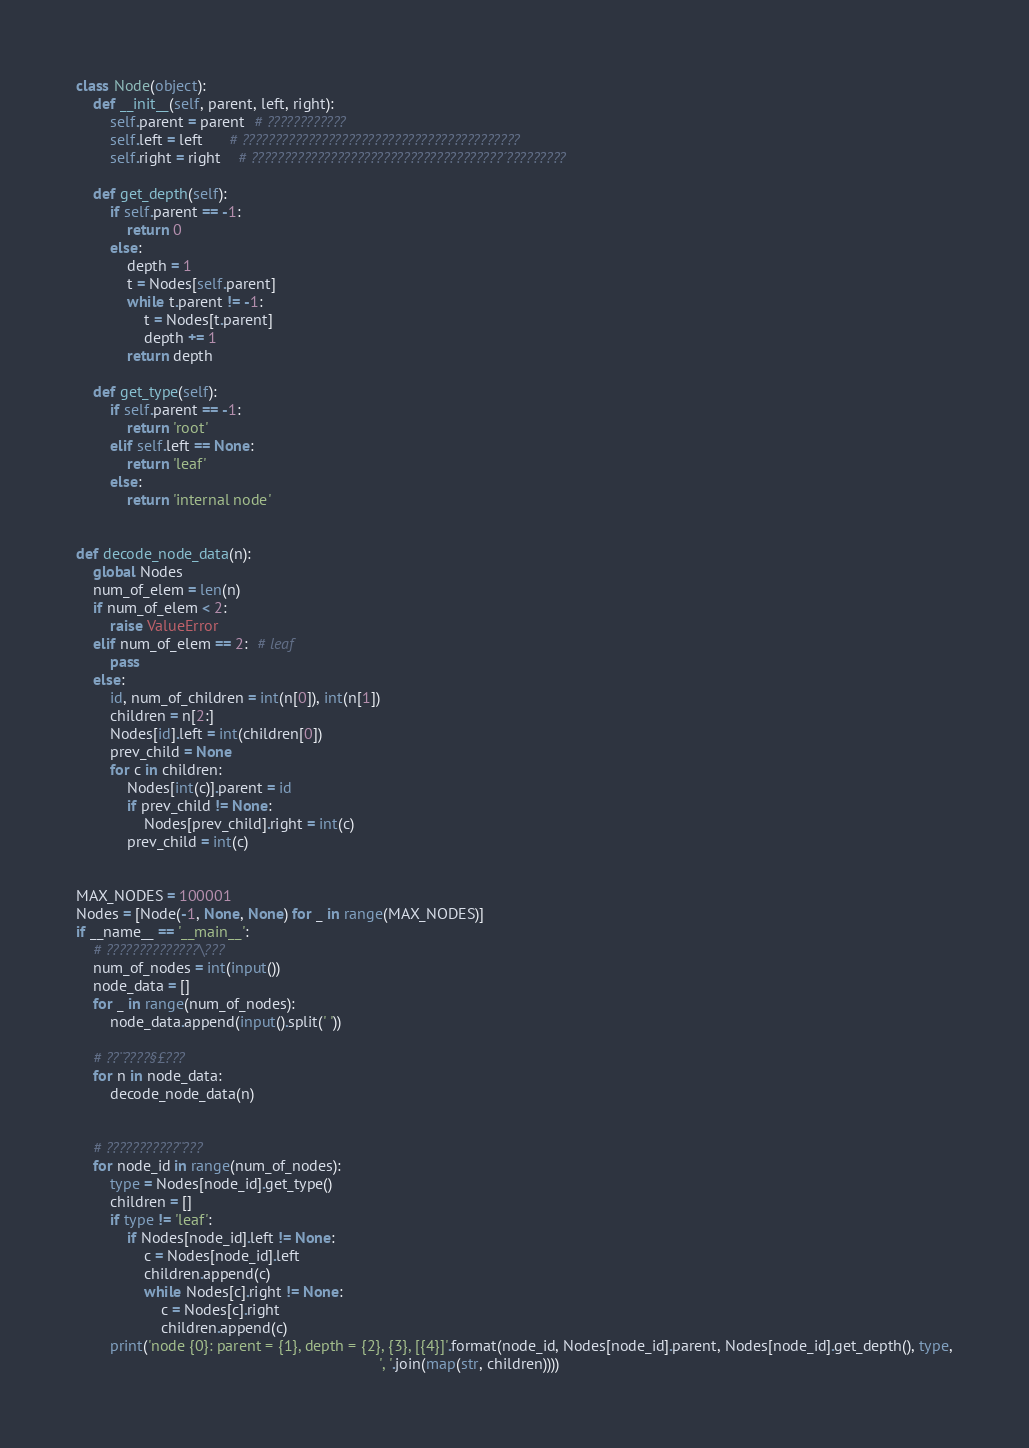Convert code to text. <code><loc_0><loc_0><loc_500><loc_500><_Python_>class Node(object):
    def __init__(self, parent, left, right):
        self.parent = parent  # ????????????
        self.left = left      # ??????????????????????????????????????????
        self.right = right    # ??????????????????????????????????????´?????????

    def get_depth(self):
        if self.parent == -1:
            return 0
        else:
            depth = 1
            t = Nodes[self.parent]
            while t.parent != -1:
                t = Nodes[t.parent]
                depth += 1
            return depth

    def get_type(self):
        if self.parent == -1:
            return 'root'
        elif self.left == None:
            return 'leaf'
        else:
            return 'internal node'


def decode_node_data(n):
    global Nodes
    num_of_elem = len(n)
    if num_of_elem < 2:
        raise ValueError
    elif num_of_elem == 2:  # leaf
        pass
    else:
        id, num_of_children = int(n[0]), int(n[1])
        children = n[2:]
        Nodes[id].left = int(children[0])
        prev_child = None
        for c in children:
            Nodes[int(c)].parent = id
            if prev_child != None:
                Nodes[prev_child].right = int(c)
            prev_child = int(c)


MAX_NODES = 100001
Nodes = [Node(-1, None, None) for _ in range(MAX_NODES)]
if __name__ == '__main__':
    # ??????????????\???
    num_of_nodes = int(input())
    node_data = []
    for _ in range(num_of_nodes):
        node_data.append(input().split(' '))

    # ??¨????§£???
    for n in node_data:
        decode_node_data(n)


    # ???????????¨???
    for node_id in range(num_of_nodes):
        type = Nodes[node_id].get_type()
        children = []
        if type != 'leaf':
            if Nodes[node_id].left != None:
                c = Nodes[node_id].left
                children.append(c)
                while Nodes[c].right != None:
                    c = Nodes[c].right
                    children.append(c)
        print('node {0}: parent = {1}, depth = {2}, {3}, [{4}]'.format(node_id, Nodes[node_id].parent, Nodes[node_id].get_depth(), type,
                                                                       ', '.join(map(str, children))))</code> 